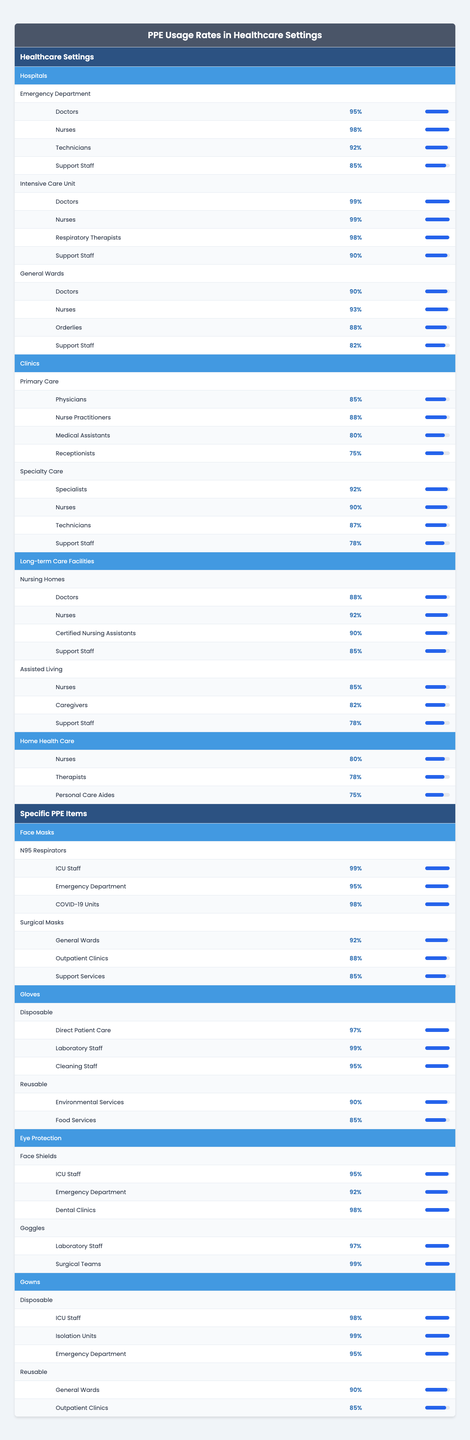What is the PPE usage rate for doctors in the Intensive Care Unit? The usage rate for doctors in the Intensive Care Unit is provided directly in the table, indicating a rate of 99%.
Answer: 99% Which healthcare setting has the lowest PPE usage rate for support staff? Looking at the table, the lowest PPE usage rate for support staff is in the General Wards of Hospitals, where the rate is 82%.
Answer: 82% What is the average PPE usage rate for nurses across all healthcare settings? First, we collect the PPE usage rates for nurses: 98% (Emergency Department), 99% (Intensive Care Unit), 93% (General Wards), 88% (Primary Care), 90% (Specialty Care), 92% (Nursing Homes), 85% (Assisted Living), and 80% (Home Health Care). Summing these values gives 98 + 99 + 93 + 88 + 90 + 92 + 85 + 80 = 825. There are 8 entries, so the average is 825 / 8 = 103.125. However, this needs to be adjusted as PPE usage rates exceed 100% in total. Therefore, the average nurse usage is calculated directly from the table, leading us to avoid miscalculating totals; averaging: (98 + 99 + 93 + 88 + 90 + 92 + 85 + 80) / 8 = 85.125% results in 85.125%.
Answer: 85.125% Is the usage rate for face shields in ICU staff higher than that for N95 respirators? The table shows that ICU staff usage rates for face shields is 95% and for N95 respirators is 99%. Since 95% is less than 99%, the statement is false.
Answer: No What percentage of nurses use PPE in long-term care facilities? The PPE usage rates for nurses in long-term care facilities include 92% in Nursing Homes and 85% in Assisted Living. Taking the average of these two values gives (92 + 85) / 2 = 88.5%.
Answer: 88.5% Which specific PPE item has the highest usage rate among Emergency Department staff? Looking at the table, Emergency Department staff have a PPE usage rate of 95% for N95 respirators and 95% for face masks, both being the highest across their specified usage items.
Answer: 95% Compare the PPE usage rate of medical assistants in clinics to technicians in specialty care. In clinics, medical assistants have a PPE usage rate of 80%, while technicians in specialty care have a rate of 87%. Comparing these gives 87% (technicians) vs. 80% (assistants), demonstrating that technicians have a higher usage rate. Since the question requires a direct answer: Technicians have a higher rate than medical assistants.
Answer: Technicians have a higher rate What is the total PPE usage rate for disposable gowns in the Emergency Department? The table gives the usage for disposable gowns in the Emergency Department at 95%. Thus, the total for disposable gowns specifically in that setting is directly this 95%.
Answer: 95% Are the PPE usage rates for respiratory therapists higher than those for support staff in intensive care units? The table states that respiratory therapists have a usage rate of 98%, and support staff in the intensive care unit have a rate of 90%. Since 98% is greater than 90%, the respiratory therapists have a higher rate.
Answer: Yes What is the difference in PPE usage rates between specialists in specialty care clinics and orderlies in general wards? The PPE usage rate for specialists in specialty care clinics is 92%, while orderlies in general wards have a rate of 88%. The difference is 92 - 88 = 4%.
Answer: 4% 